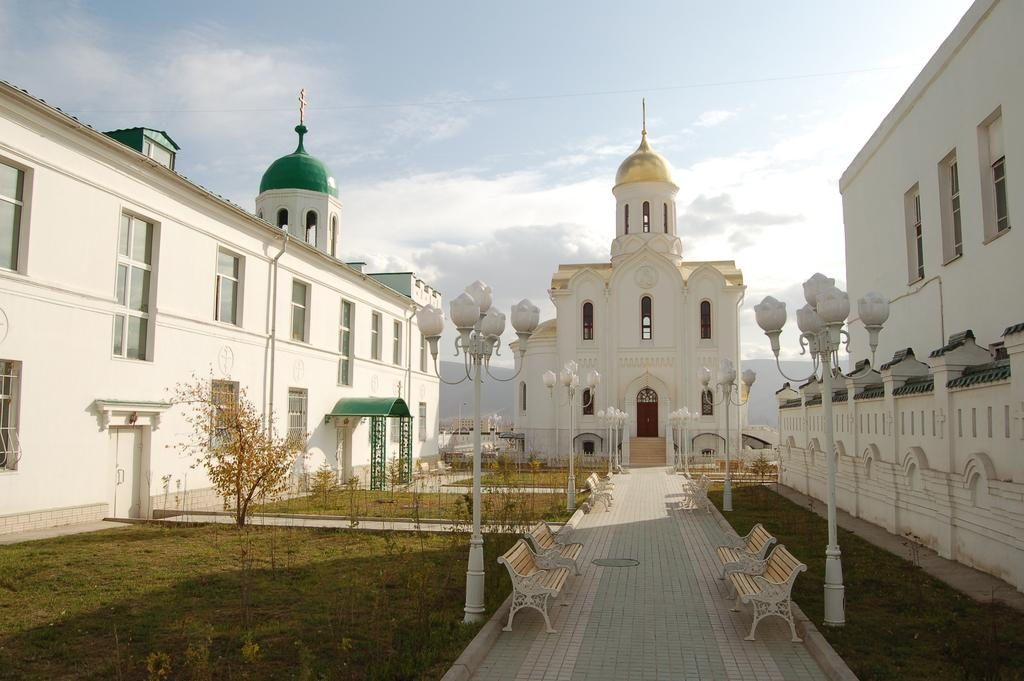What type of structures are present in the image? There are buildings in the image. What feature do the buildings have? The buildings have windows. What type of vegetation is visible in the image? There is grass in the image. What type of street furniture is present in the image? There is a light pole and benches in the image. What type of path is visible in the image? There is a footpath in the image. What is the condition of the sky in the image? The sky is cloudy in the image. What type of lunch is the girl eating in the image? There is no girl or lunch present in the image. What type of house is visible in the image? There is no house visible in the image; only buildings are mentioned. 